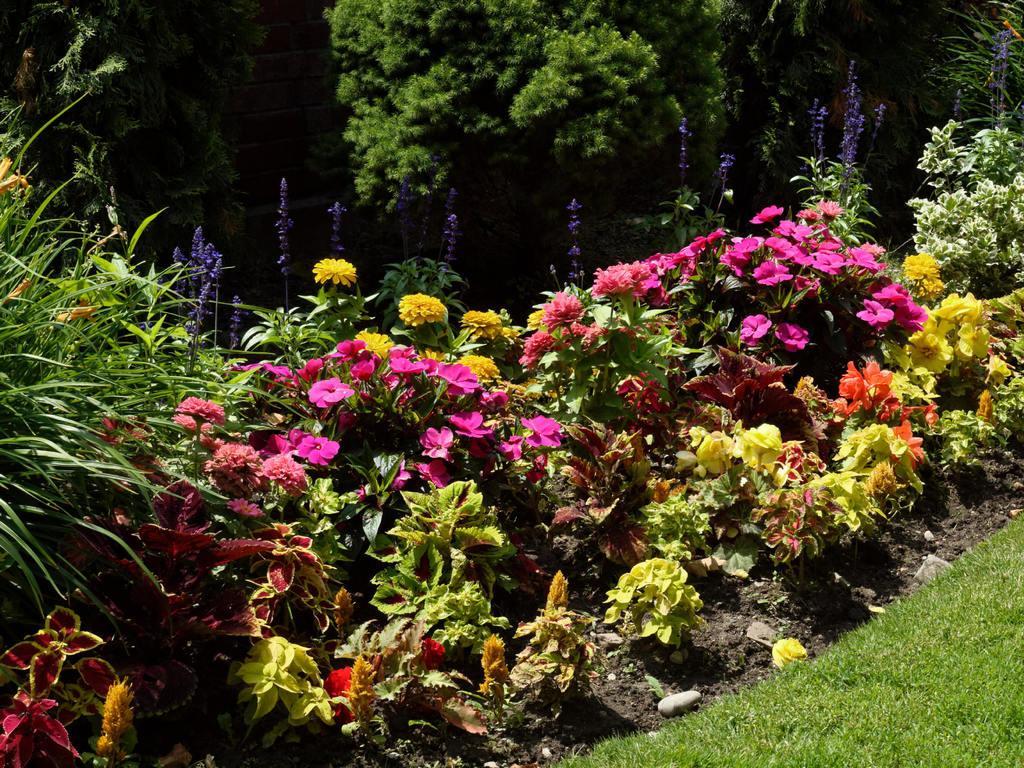Can you describe this image briefly? In this image there are few plants having flowers are on the land having grass. Top of the image there are few trees. 